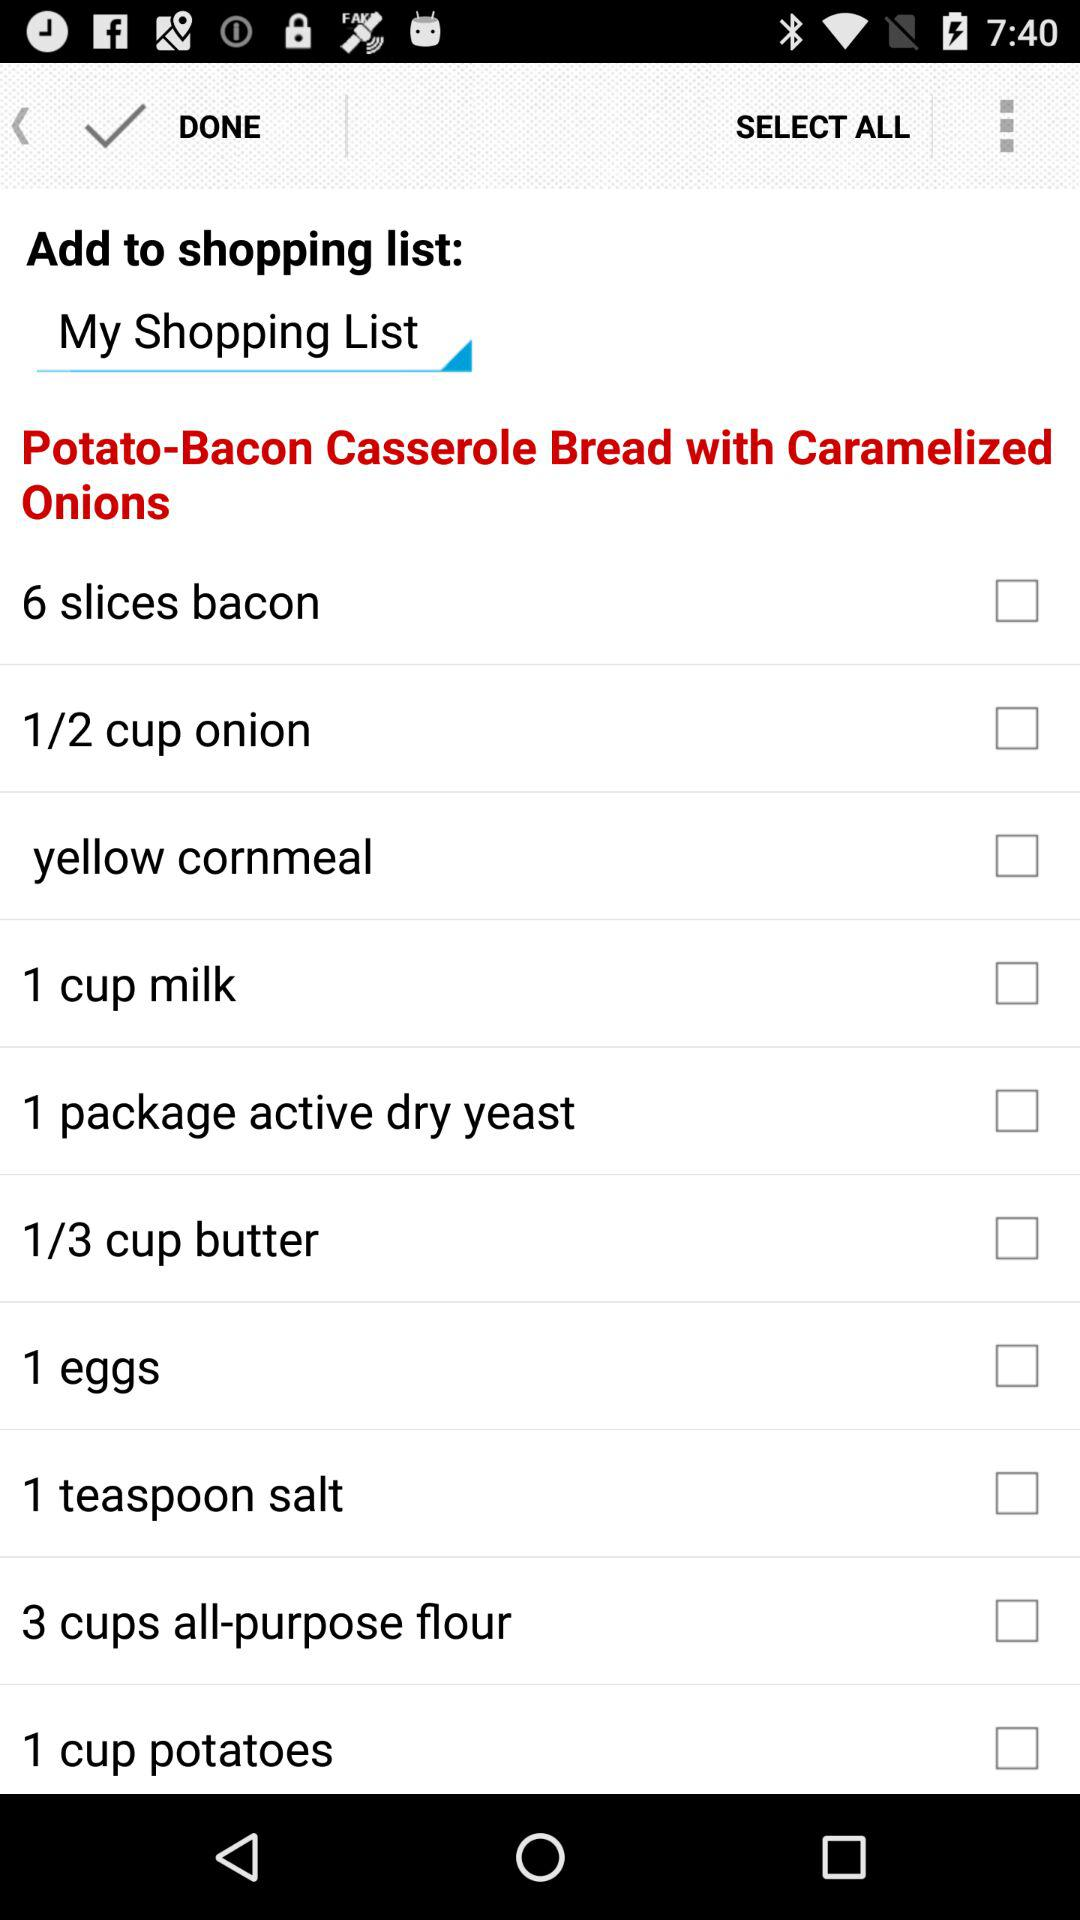What's the number of slices of bacon? The number is 6. 